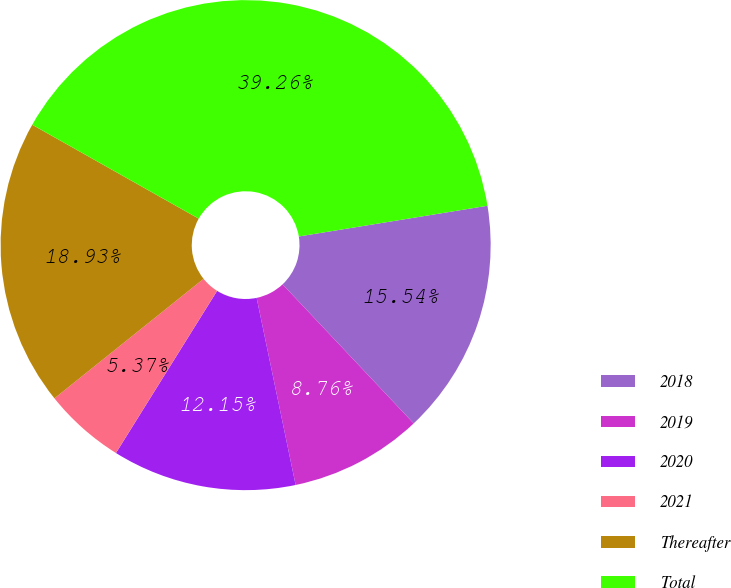Convert chart. <chart><loc_0><loc_0><loc_500><loc_500><pie_chart><fcel>2018<fcel>2019<fcel>2020<fcel>2021<fcel>Thereafter<fcel>Total<nl><fcel>15.54%<fcel>8.76%<fcel>12.15%<fcel>5.37%<fcel>18.93%<fcel>39.26%<nl></chart> 